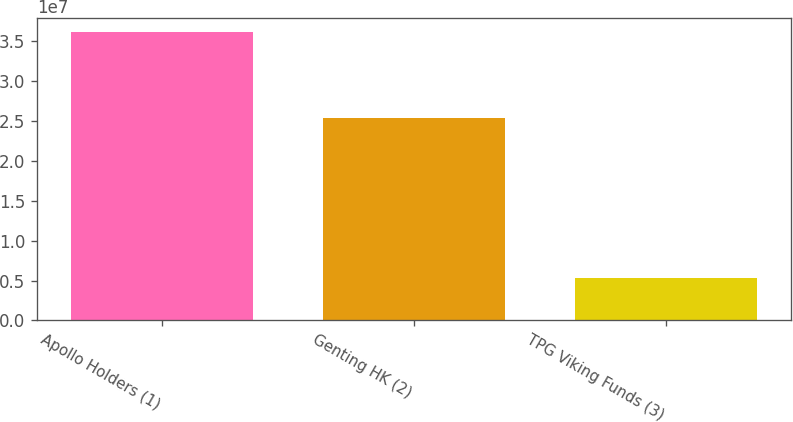Convert chart. <chart><loc_0><loc_0><loc_500><loc_500><bar_chart><fcel>Apollo Holders (1)<fcel>Genting HK (2)<fcel>TPG Viking Funds (3)<nl><fcel>3.61038e+07<fcel>2.53983e+07<fcel>5.32983e+06<nl></chart> 